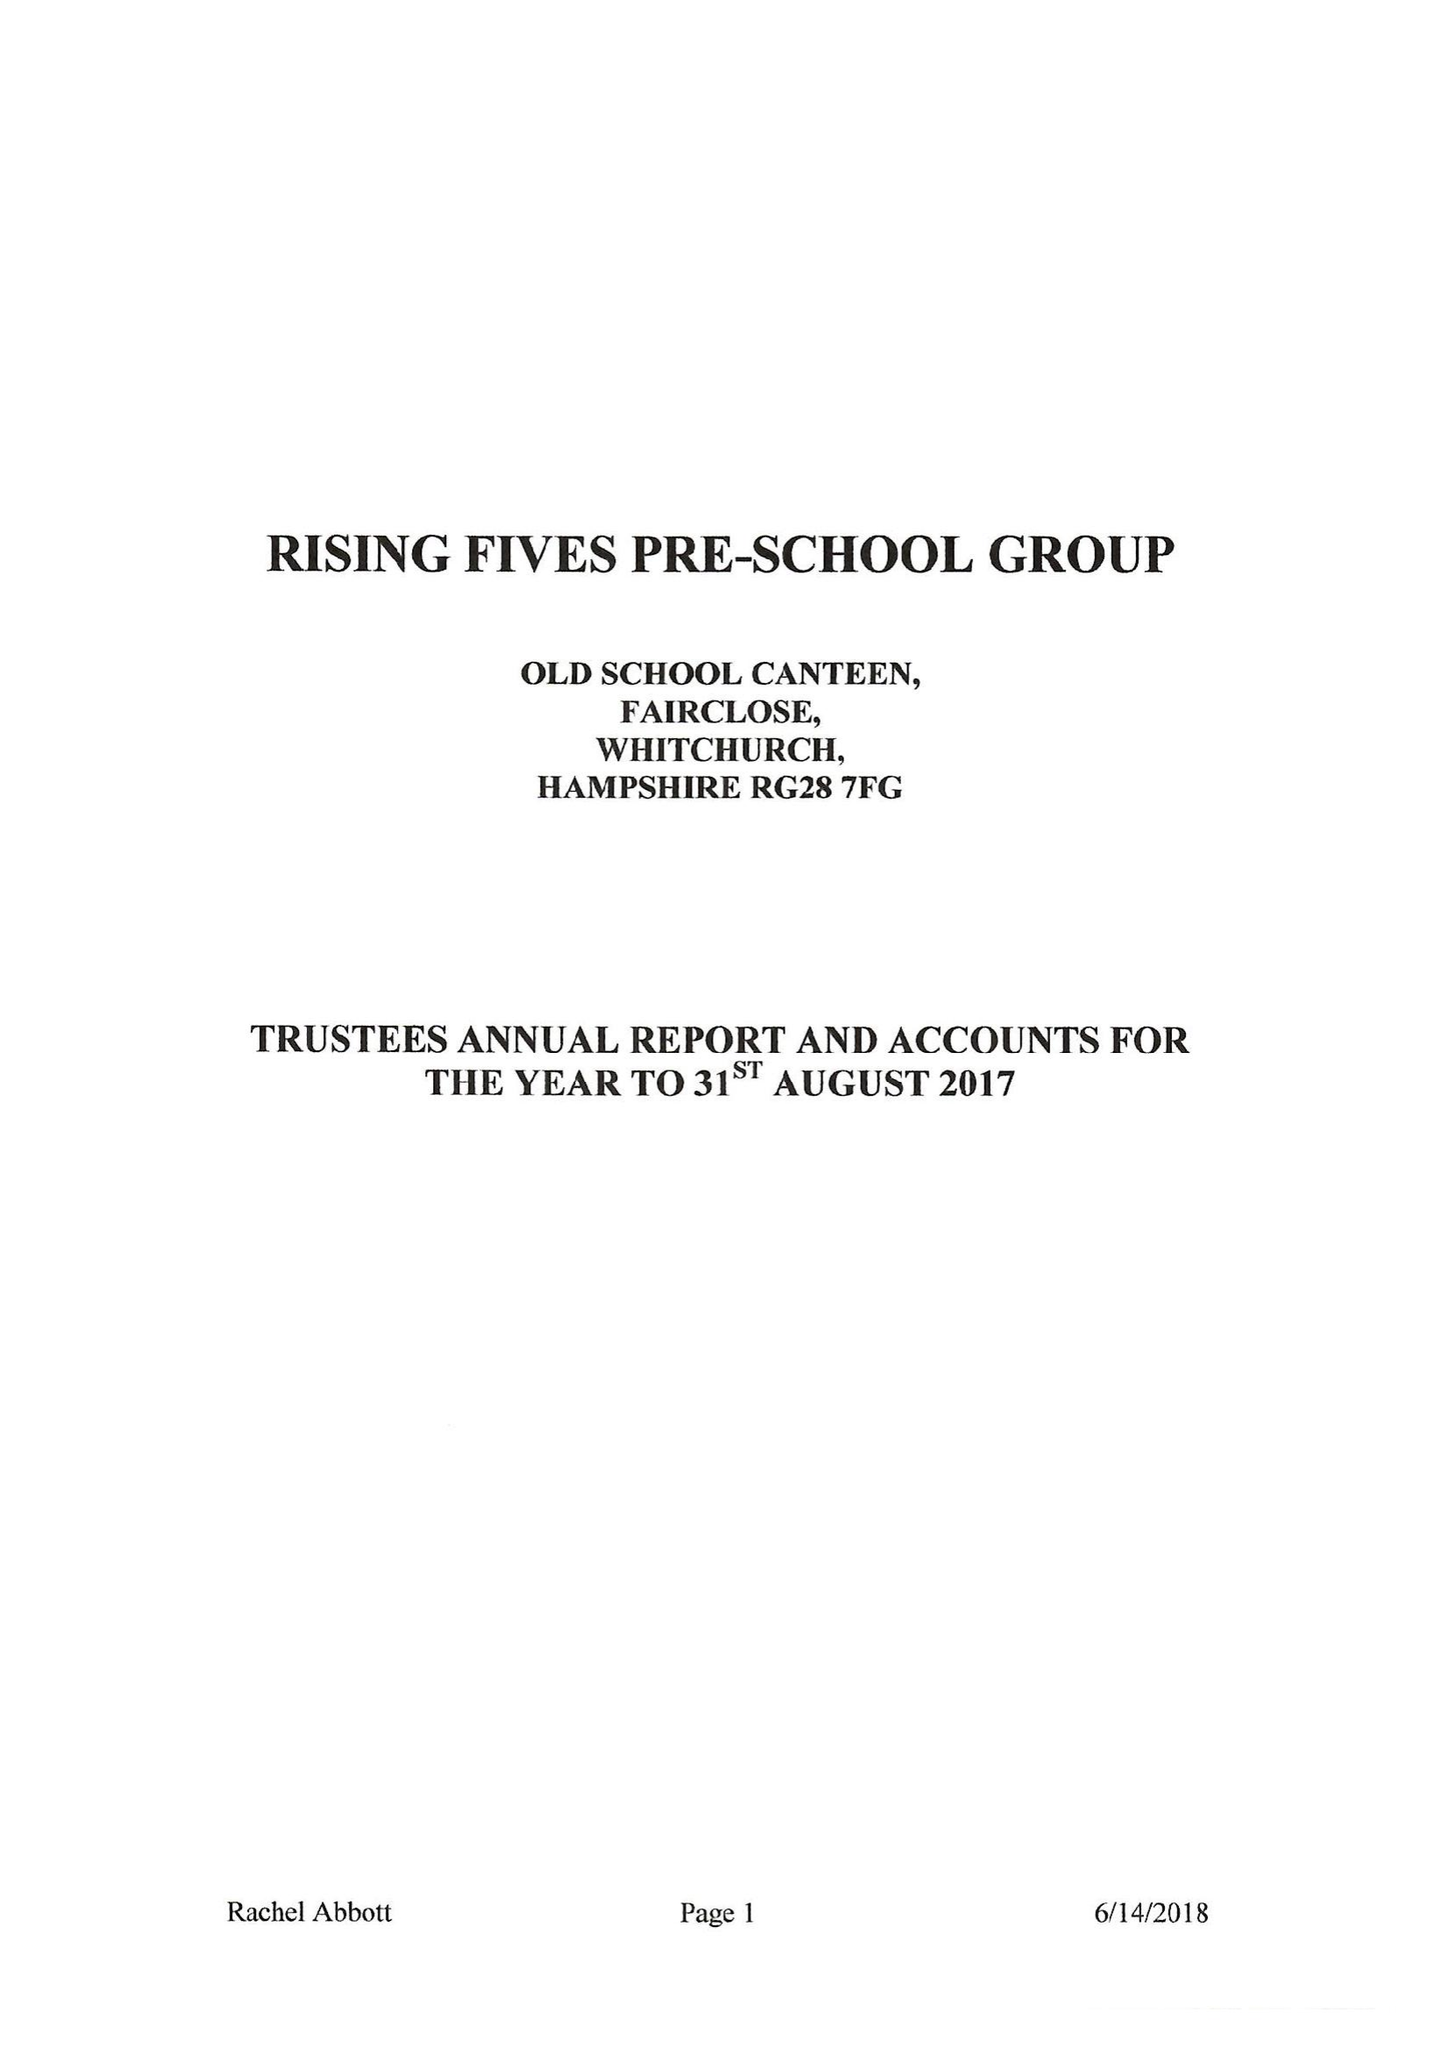What is the value for the charity_name?
Answer the question using a single word or phrase. Rising Fives Pre-School Group 